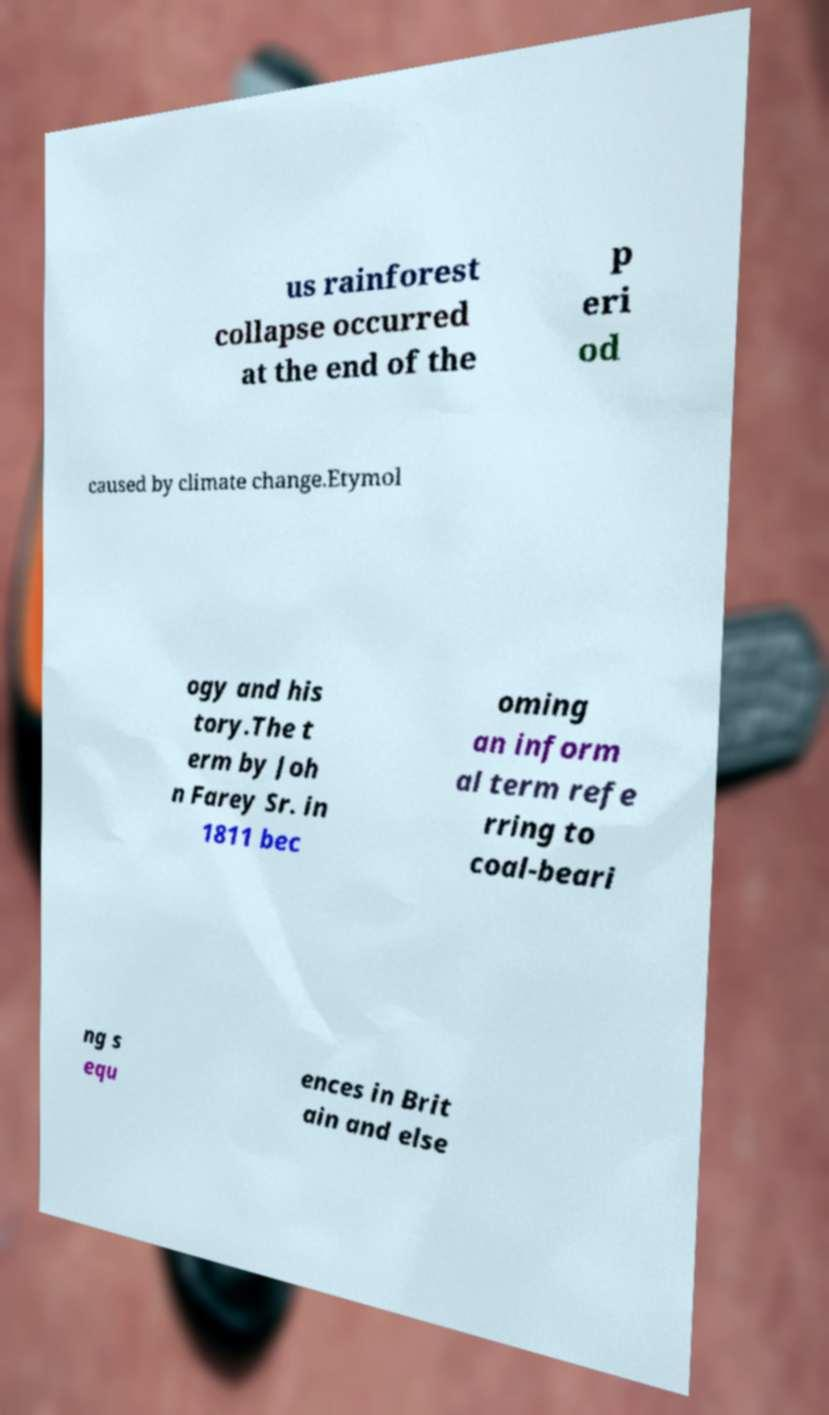Can you read and provide the text displayed in the image?This photo seems to have some interesting text. Can you extract and type it out for me? us rainforest collapse occurred at the end of the p eri od caused by climate change.Etymol ogy and his tory.The t erm by Joh n Farey Sr. in 1811 bec oming an inform al term refe rring to coal-beari ng s equ ences in Brit ain and else 